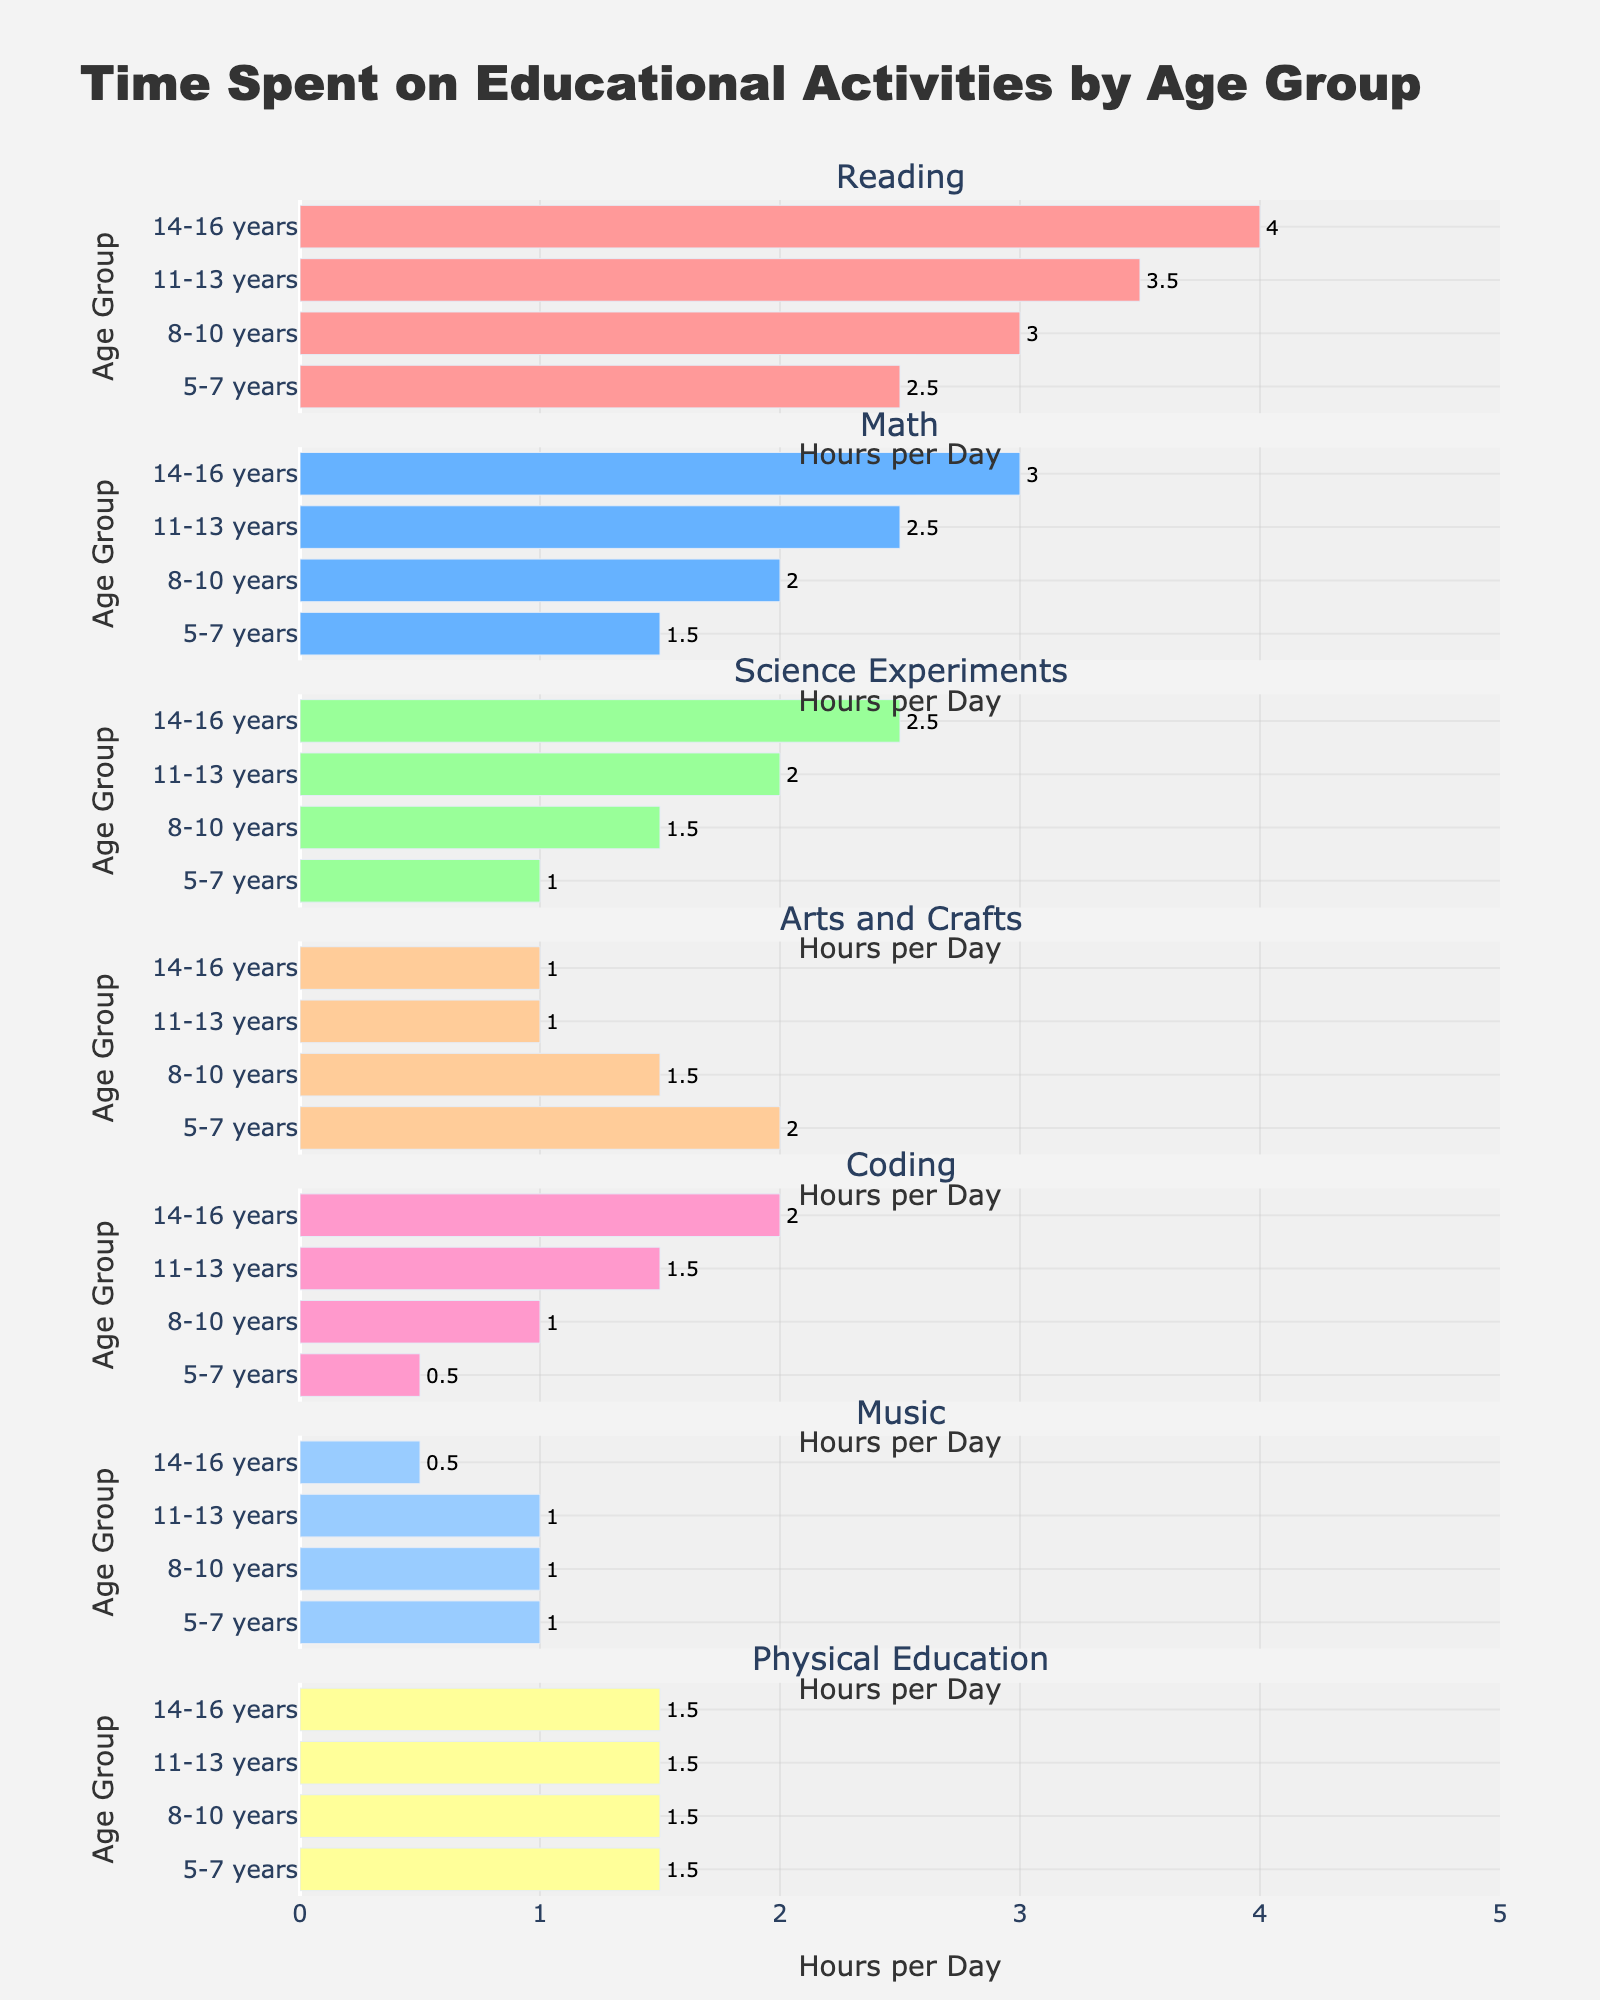What activity do 5-7 years old children spend the most time on? We look at the bar lengths in the subplot for 5-7 years old children. The longest bar corresponds to "Reading".
Answer: Reading Between which age groups does the time spent on Coding increase the most? Compare the differences in the bar lengths between consecutive age groups in the "Coding" subplot. The largest increase is from  5-7 years (0.5) to 8-10 years (1), which is an increase of 0.5 hours.
Answer: 8-10 years to 11-13 years How many educational activities involve at least 2 hours of time for the 14-16 years age group? Count the bars in the 14-16 years age group that reach or exceed the 2-hour mark. These are Reading, Math, Science Experiments, and Coding.
Answer: 4 activities For which age group is the time spent on Science Experiments the same as the time spent on Physical Education? Compare the bar lengths for "Science Experiments" and "Physical Education" in each age group. The 11-13 years group spends 2 hours on both activities.
Answer: 11-13 years Which activity shows consistent growth in time spent across all age groups? Check the bars of each activity across all age groups and observe which activity shows a gradual increase in time. "Reading" shows consistent growth from 2.5 to 4 hours.
Answer: Reading What is the difference in time spent on Arts and Crafts between the youngest and oldest age groups? Subtract the time spent on Arts and Crafts in the 14-16 years group (1 hour) from the 5-7 years group (2 hours).
Answer: 1 hour Which age group spends the least time on Music? Look at the bars in the "Music" subplot across all age groups. The 14-16 years group has the shortest bar at 0.5 hours.
Answer: 14-16 years What is the average time spent on Mathematics across all age groups? Add the time spent on Mathematics for all age groups (1.5, 2, 2.5, 3) and divide by the number of age groups (4). (1.5 + 2 + 2.5 + 3) / 4 = 2.25
Answer: 2.25 hours How does the time spent on Physical Education compare between the 5-7 years and 8-10 years age groups? Compare the bar lengths for "Physical Education" in the 5-7 years group (1.5) and the 8-10 years group (1.5). They are equal.
Answer: Same 